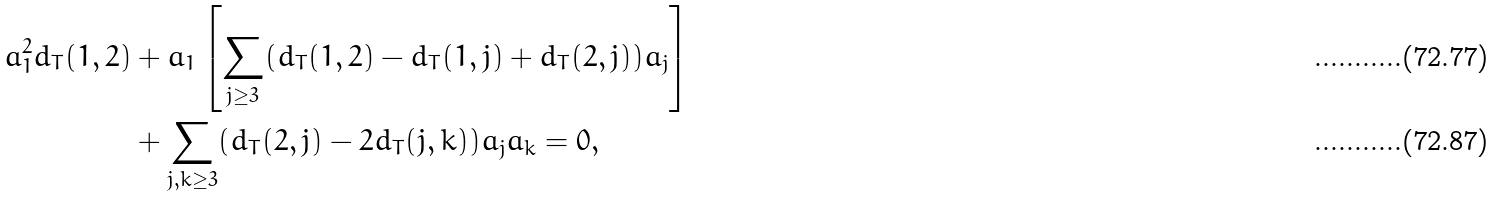Convert formula to latex. <formula><loc_0><loc_0><loc_500><loc_500>a _ { 1 } ^ { 2 } d _ { T } ( 1 , 2 ) & + a _ { 1 } \left [ \sum _ { j \geq 3 } ( d _ { T } ( 1 , 2 ) - d _ { T } ( 1 , j ) + d _ { T } ( 2 , j ) ) a _ { j } \right ] \\ & + \sum _ { j , k \geq 3 } ( d _ { T } ( 2 , j ) - 2 d _ { T } ( j , k ) ) a _ { j } a _ { k } = 0 ,</formula> 